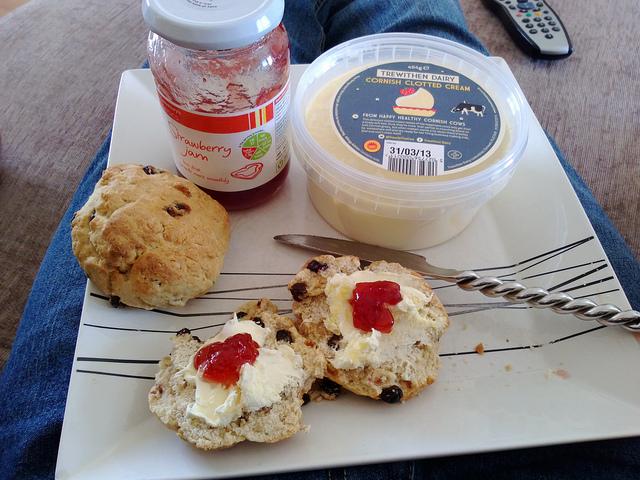What type of fruit is the juice from?
Keep it brief. Strawberry. Is the person sitting or standing?
Quick response, please. Sitting. Is the food tasty?
Short answer required. Yes. What is in the jar?
Be succinct. Jam. 